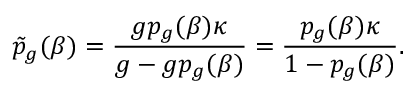<formula> <loc_0><loc_0><loc_500><loc_500>\tilde { p } _ { g } ( \beta ) = \frac { g p _ { g } ( \beta ) \kappa } { g - g p _ { g } ( \beta ) } = \frac { p _ { g } ( \beta ) \kappa } { 1 - p _ { g } ( \beta ) } .</formula> 